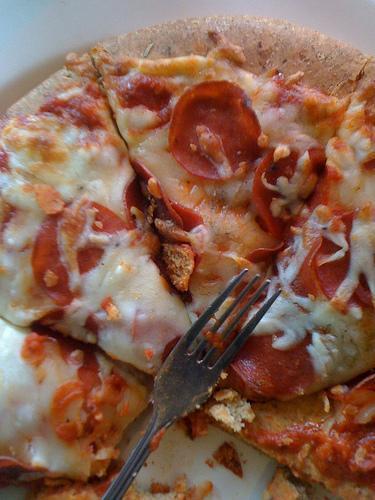How many pizza slices are visible?
Give a very brief answer. 5. How many pizza slices are completely in the picture?
Give a very brief answer. 1. 